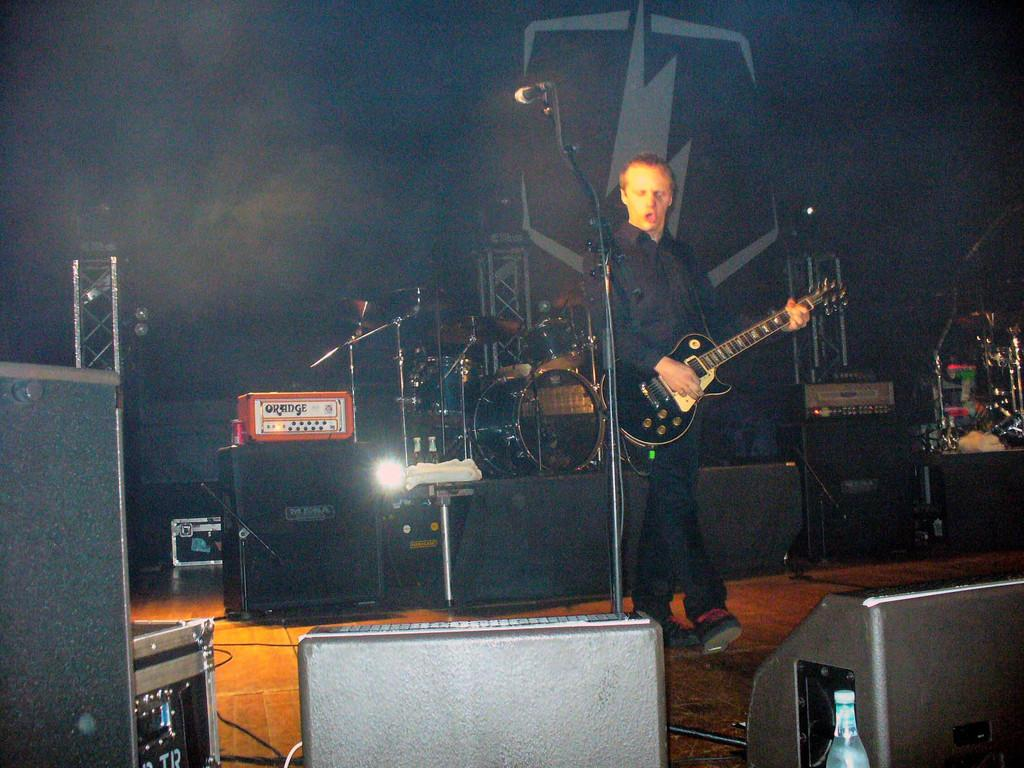What is the main subject of the image? The main subject of the image is a man standing in the center. What is the man holding in his hand? The man is holding a guitar in his hand. What is the man doing with the guitar? The man is singing a song while holding the guitar. What object is present in the center of the image besides the man? There is a microphone in the center of the image. How many boys are visible in the image? There are no boys visible in the image; it features a man holding a guitar and singing. Is there a light bulb present in the image? There is no light bulb present in the image. 